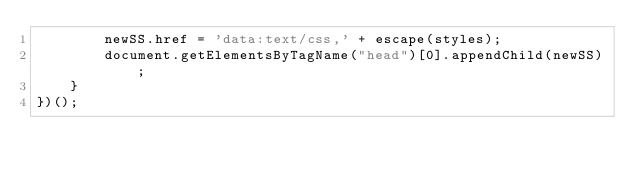Convert code to text. <code><loc_0><loc_0><loc_500><loc_500><_JavaScript_>        newSS.href = 'data:text/css,' + escape(styles);
        document.getElementsByTagName("head")[0].appendChild(newSS);
    }
})();
</code> 